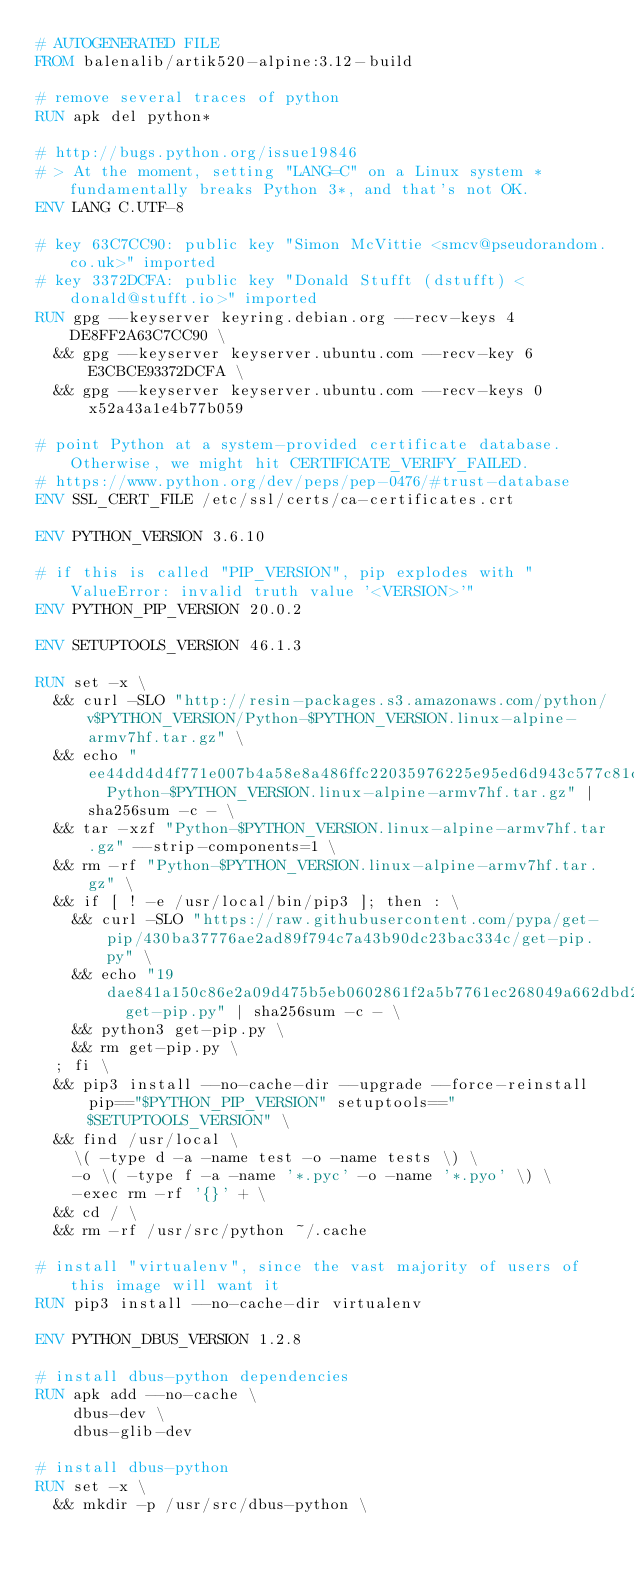<code> <loc_0><loc_0><loc_500><loc_500><_Dockerfile_># AUTOGENERATED FILE
FROM balenalib/artik520-alpine:3.12-build

# remove several traces of python
RUN apk del python*

# http://bugs.python.org/issue19846
# > At the moment, setting "LANG=C" on a Linux system *fundamentally breaks Python 3*, and that's not OK.
ENV LANG C.UTF-8

# key 63C7CC90: public key "Simon McVittie <smcv@pseudorandom.co.uk>" imported
# key 3372DCFA: public key "Donald Stufft (dstufft) <donald@stufft.io>" imported
RUN gpg --keyserver keyring.debian.org --recv-keys 4DE8FF2A63C7CC90 \
	&& gpg --keyserver keyserver.ubuntu.com --recv-key 6E3CBCE93372DCFA \
	&& gpg --keyserver keyserver.ubuntu.com --recv-keys 0x52a43a1e4b77b059

# point Python at a system-provided certificate database. Otherwise, we might hit CERTIFICATE_VERIFY_FAILED.
# https://www.python.org/dev/peps/pep-0476/#trust-database
ENV SSL_CERT_FILE /etc/ssl/certs/ca-certificates.crt

ENV PYTHON_VERSION 3.6.10

# if this is called "PIP_VERSION", pip explodes with "ValueError: invalid truth value '<VERSION>'"
ENV PYTHON_PIP_VERSION 20.0.2

ENV SETUPTOOLS_VERSION 46.1.3

RUN set -x \
	&& curl -SLO "http://resin-packages.s3.amazonaws.com/python/v$PYTHON_VERSION/Python-$PYTHON_VERSION.linux-alpine-armv7hf.tar.gz" \
	&& echo "ee44dd4d4f771e007b4a58e8a486ffc22035976225e95ed6d943c577c81dee88  Python-$PYTHON_VERSION.linux-alpine-armv7hf.tar.gz" | sha256sum -c - \
	&& tar -xzf "Python-$PYTHON_VERSION.linux-alpine-armv7hf.tar.gz" --strip-components=1 \
	&& rm -rf "Python-$PYTHON_VERSION.linux-alpine-armv7hf.tar.gz" \
	&& if [ ! -e /usr/local/bin/pip3 ]; then : \
		&& curl -SLO "https://raw.githubusercontent.com/pypa/get-pip/430ba37776ae2ad89f794c7a43b90dc23bac334c/get-pip.py" \
		&& echo "19dae841a150c86e2a09d475b5eb0602861f2a5b7761ec268049a662dbd2bd0c  get-pip.py" | sha256sum -c - \
		&& python3 get-pip.py \
		&& rm get-pip.py \
	; fi \
	&& pip3 install --no-cache-dir --upgrade --force-reinstall pip=="$PYTHON_PIP_VERSION" setuptools=="$SETUPTOOLS_VERSION" \
	&& find /usr/local \
		\( -type d -a -name test -o -name tests \) \
		-o \( -type f -a -name '*.pyc' -o -name '*.pyo' \) \
		-exec rm -rf '{}' + \
	&& cd / \
	&& rm -rf /usr/src/python ~/.cache

# install "virtualenv", since the vast majority of users of this image will want it
RUN pip3 install --no-cache-dir virtualenv

ENV PYTHON_DBUS_VERSION 1.2.8

# install dbus-python dependencies 
RUN apk add --no-cache \
		dbus-dev \
		dbus-glib-dev

# install dbus-python
RUN set -x \
	&& mkdir -p /usr/src/dbus-python \</code> 